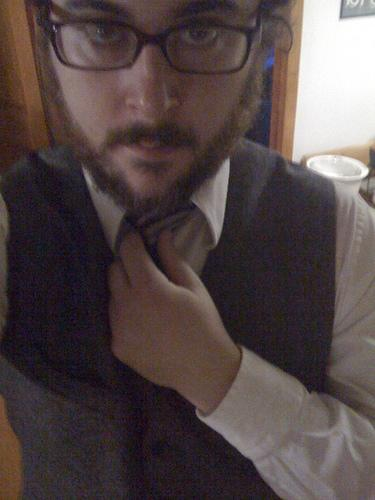What is the man adjusting?

Choices:
A) hat
B) belt
C) tie
D) glasses tie 